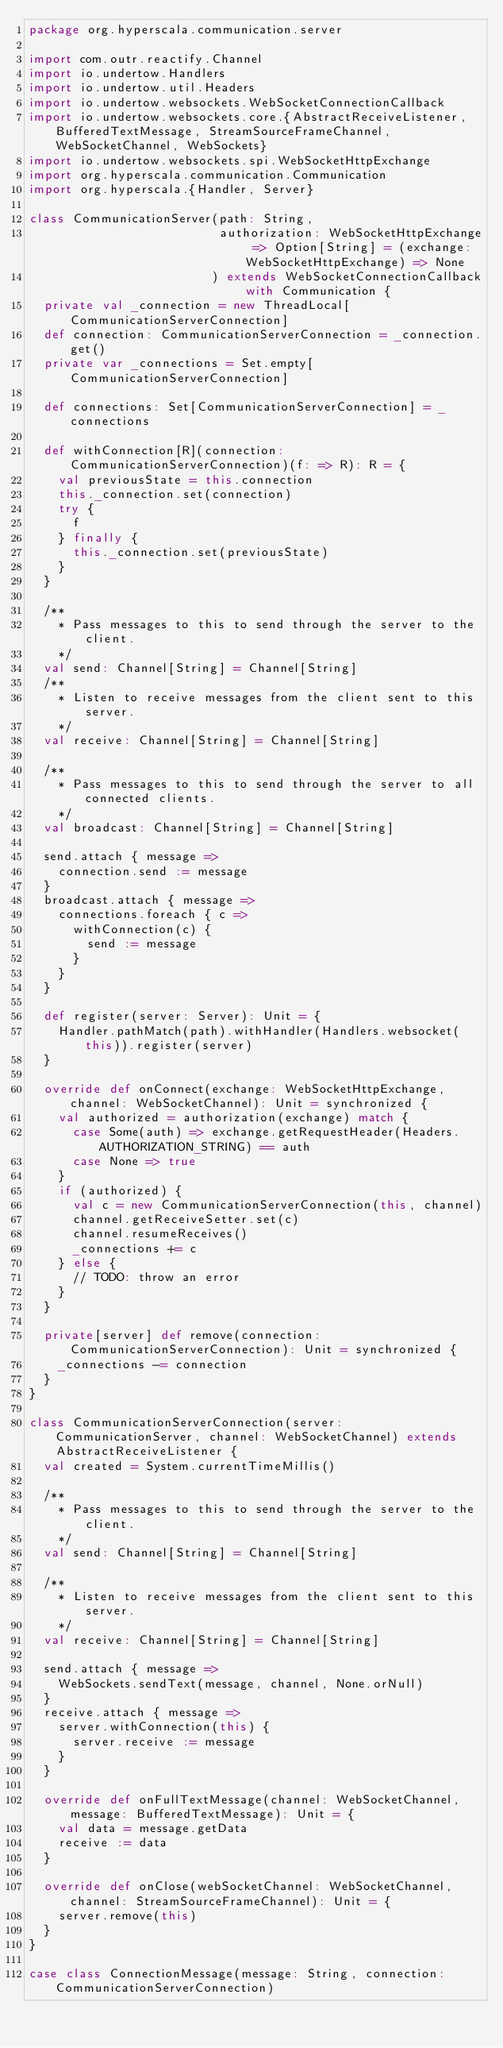<code> <loc_0><loc_0><loc_500><loc_500><_Scala_>package org.hyperscala.communication.server

import com.outr.reactify.Channel
import io.undertow.Handlers
import io.undertow.util.Headers
import io.undertow.websockets.WebSocketConnectionCallback
import io.undertow.websockets.core.{AbstractReceiveListener, BufferedTextMessage, StreamSourceFrameChannel, WebSocketChannel, WebSockets}
import io.undertow.websockets.spi.WebSocketHttpExchange
import org.hyperscala.communication.Communication
import org.hyperscala.{Handler, Server}

class CommunicationServer(path: String,
                          authorization: WebSocketHttpExchange => Option[String] = (exchange: WebSocketHttpExchange) => None
                         ) extends WebSocketConnectionCallback with Communication {
  private val _connection = new ThreadLocal[CommunicationServerConnection]
  def connection: CommunicationServerConnection = _connection.get()
  private var _connections = Set.empty[CommunicationServerConnection]

  def connections: Set[CommunicationServerConnection] = _connections

  def withConnection[R](connection: CommunicationServerConnection)(f: => R): R = {
    val previousState = this.connection
    this._connection.set(connection)
    try {
      f
    } finally {
      this._connection.set(previousState)
    }
  }

  /**
    * Pass messages to this to send through the server to the client.
    */
  val send: Channel[String] = Channel[String]
  /**
    * Listen to receive messages from the client sent to this server.
    */
  val receive: Channel[String] = Channel[String]

  /**
    * Pass messages to this to send through the server to all connected clients.
    */
  val broadcast: Channel[String] = Channel[String]

  send.attach { message =>
    connection.send := message
  }
  broadcast.attach { message =>
    connections.foreach { c =>
      withConnection(c) {
        send := message
      }
    }
  }

  def register(server: Server): Unit = {
    Handler.pathMatch(path).withHandler(Handlers.websocket(this)).register(server)
  }

  override def onConnect(exchange: WebSocketHttpExchange, channel: WebSocketChannel): Unit = synchronized {
    val authorized = authorization(exchange) match {
      case Some(auth) => exchange.getRequestHeader(Headers.AUTHORIZATION_STRING) == auth
      case None => true
    }
    if (authorized) {
      val c = new CommunicationServerConnection(this, channel)
      channel.getReceiveSetter.set(c)
      channel.resumeReceives()
      _connections += c
    } else {
      // TODO: throw an error
    }
  }

  private[server] def remove(connection: CommunicationServerConnection): Unit = synchronized {
    _connections -= connection
  }
}

class CommunicationServerConnection(server: CommunicationServer, channel: WebSocketChannel) extends AbstractReceiveListener {
  val created = System.currentTimeMillis()

  /**
    * Pass messages to this to send through the server to the client.
    */
  val send: Channel[String] = Channel[String]

  /**
    * Listen to receive messages from the client sent to this server.
    */
  val receive: Channel[String] = Channel[String]

  send.attach { message =>
    WebSockets.sendText(message, channel, None.orNull)
  }
  receive.attach { message =>
    server.withConnection(this) {
      server.receive := message
    }
  }

  override def onFullTextMessage(channel: WebSocketChannel, message: BufferedTextMessage): Unit = {
    val data = message.getData
    receive := data
  }

  override def onClose(webSocketChannel: WebSocketChannel, channel: StreamSourceFrameChannel): Unit = {
    server.remove(this)
  }
}

case class ConnectionMessage(message: String, connection: CommunicationServerConnection)</code> 